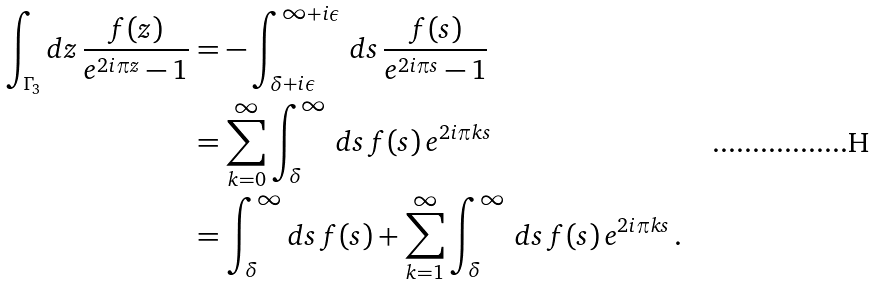<formula> <loc_0><loc_0><loc_500><loc_500>\int _ { \Gamma _ { 3 } } d z \, \frac { f ( z ) } { e ^ { 2 i \pi z } - 1 } & = - \int _ { \delta + i \epsilon } ^ { \infty + i \epsilon } \, d s \, \frac { f ( s ) } { e ^ { 2 i \pi s } - 1 } \\ & = \sum _ { k = 0 } ^ { \infty } \int _ { \delta } ^ { \infty } \, d s \, f ( s ) \, e ^ { 2 i \pi k s } \\ & = \int _ { \delta } ^ { \infty } d s \, f ( s ) + \sum _ { k = 1 } ^ { \infty } \int _ { \delta } ^ { \infty } \, d s \, f ( s ) \, e ^ { 2 i \pi k s } \, .</formula> 